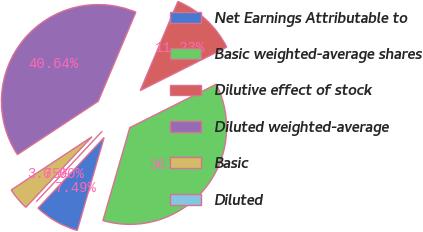Convert chart to OTSL. <chart><loc_0><loc_0><loc_500><loc_500><pie_chart><fcel>Net Earnings Attributable to<fcel>Basic weighted-average shares<fcel>Dilutive effect of stock<fcel>Diluted weighted-average<fcel>Basic<fcel>Diluted<nl><fcel>7.49%<fcel>36.89%<fcel>11.23%<fcel>40.64%<fcel>3.75%<fcel>0.0%<nl></chart> 